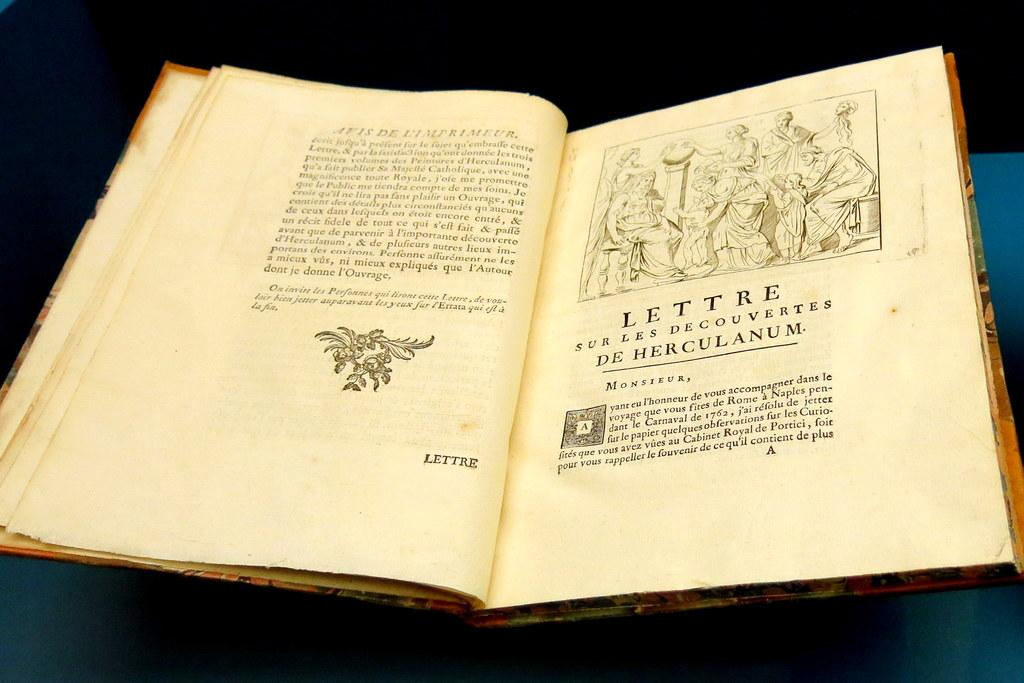<image>
Give a short and clear explanation of the subsequent image. A book opened to the page that reads Lettre Sur Les Decouvertes De Herculanum. 